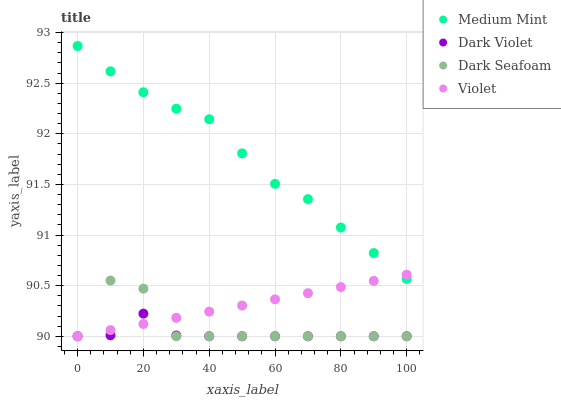Does Dark Violet have the minimum area under the curve?
Answer yes or no. Yes. Does Medium Mint have the maximum area under the curve?
Answer yes or no. Yes. Does Dark Seafoam have the minimum area under the curve?
Answer yes or no. No. Does Dark Seafoam have the maximum area under the curve?
Answer yes or no. No. Is Violet the smoothest?
Answer yes or no. Yes. Is Dark Seafoam the roughest?
Answer yes or no. Yes. Is Dark Violet the smoothest?
Answer yes or no. No. Is Dark Violet the roughest?
Answer yes or no. No. Does Dark Seafoam have the lowest value?
Answer yes or no. Yes. Does Medium Mint have the highest value?
Answer yes or no. Yes. Does Dark Seafoam have the highest value?
Answer yes or no. No. Is Dark Violet less than Medium Mint?
Answer yes or no. Yes. Is Medium Mint greater than Dark Violet?
Answer yes or no. Yes. Does Dark Violet intersect Dark Seafoam?
Answer yes or no. Yes. Is Dark Violet less than Dark Seafoam?
Answer yes or no. No. Is Dark Violet greater than Dark Seafoam?
Answer yes or no. No. Does Dark Violet intersect Medium Mint?
Answer yes or no. No. 